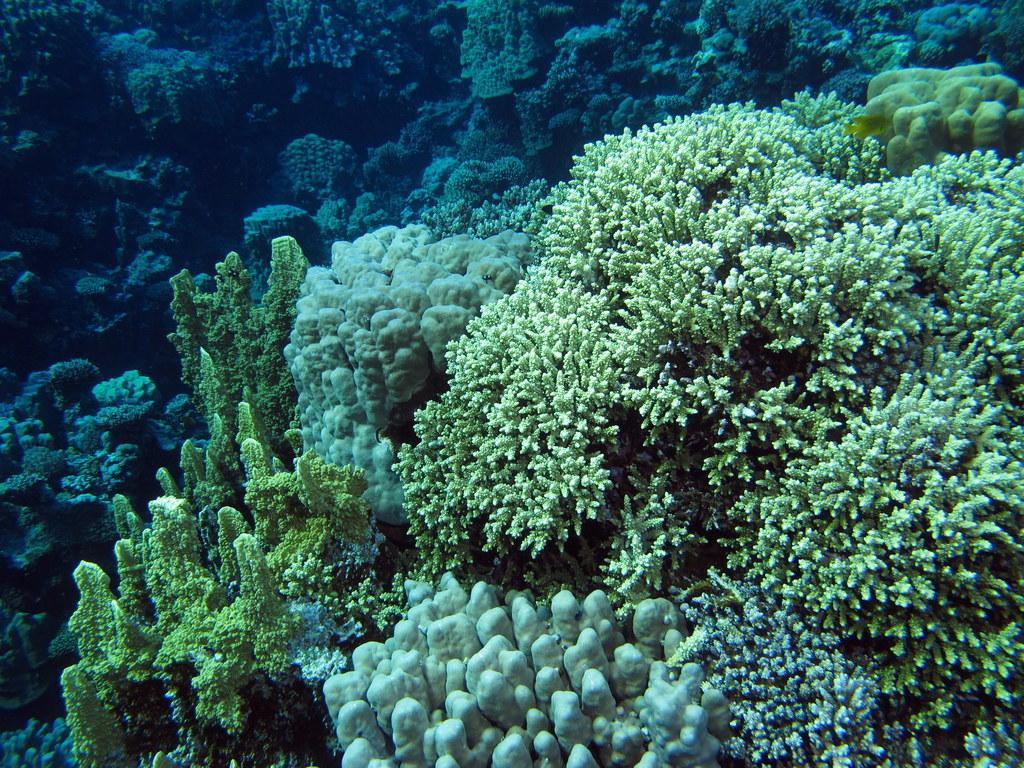Please provide a concise description of this image. In the image we can see underwater plants. 